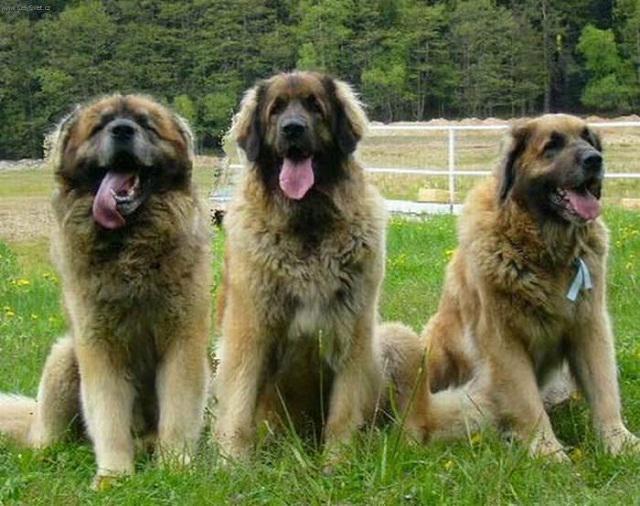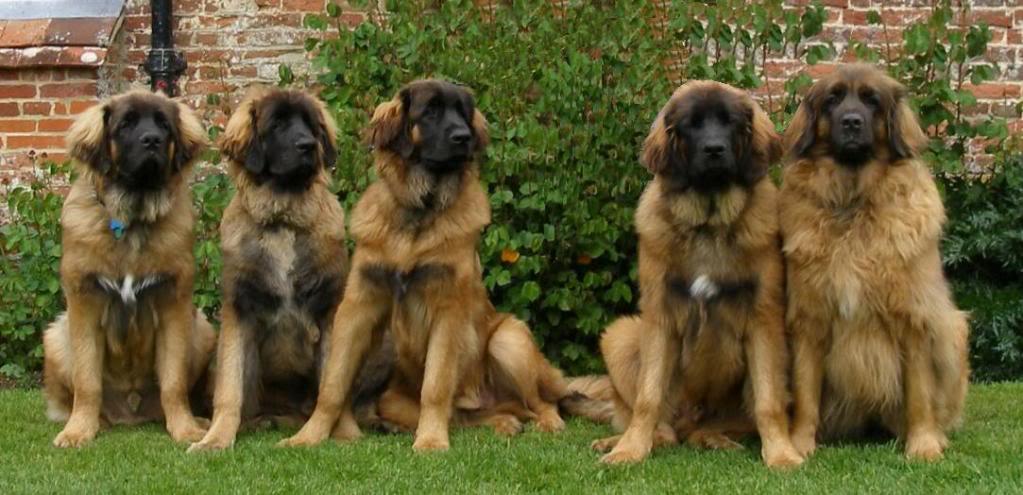The first image is the image on the left, the second image is the image on the right. Evaluate the accuracy of this statement regarding the images: "At least one image in the pair shows at least two mammals.". Is it true? Answer yes or no. Yes. The first image is the image on the left, the second image is the image on the right. Analyze the images presented: Is the assertion "Both images show a single adult dog looking left." valid? Answer yes or no. No. 